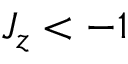<formula> <loc_0><loc_0><loc_500><loc_500>J _ { z } < - 1</formula> 